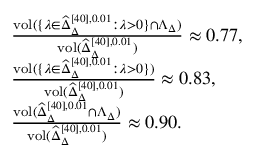Convert formula to latex. <formula><loc_0><loc_0><loc_500><loc_500>\begin{array} { r l } & { \frac { v o l ( \{ \lambda \in \widehat { \Delta } _ { \Delta } ^ { [ 4 0 ] , 0 . 0 1 } \colon \lambda > 0 \} \cap \Lambda _ { \Delta } ) } { v o l ( \widehat { \Delta } _ { \Delta } ^ { [ 4 0 ] , 0 . 0 1 } ) } \approx 0 . 7 7 , } \\ & { \frac { v o l ( \{ \lambda \in \widehat { \Delta } _ { \Delta } ^ { [ 4 0 ] , 0 . 0 1 } \colon \lambda > 0 \} ) } { v o l ( \widehat { \Delta } _ { \Delta } ^ { [ 4 0 ] , 0 . 0 1 } ) } \approx 0 . 8 3 , } \\ & { \frac { v o l ( \widehat { \Delta } _ { \Delta } ^ { [ 4 0 ] , 0 . 0 1 } \cap \Lambda _ { \Delta } ) } { v o l ( \widehat { \Delta } _ { \Delta } ^ { [ 4 0 ] , 0 . 0 1 } ) } \approx 0 . 9 0 . } \end{array}</formula> 